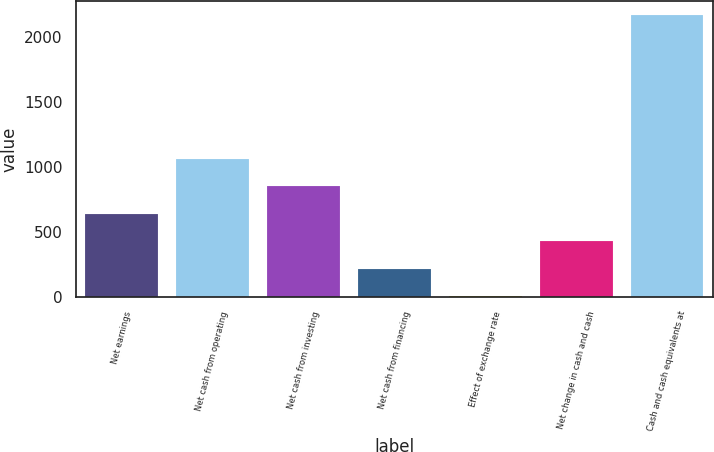Convert chart. <chart><loc_0><loc_0><loc_500><loc_500><bar_chart><fcel>Net earnings<fcel>Net cash from operating<fcel>Net cash from investing<fcel>Net cash from financing<fcel>Effect of exchange rate<fcel>Net change in cash and cash<fcel>Cash and cash equivalents at<nl><fcel>641.3<fcel>1063.5<fcel>852.4<fcel>219.1<fcel>8<fcel>430.2<fcel>2170.1<nl></chart> 